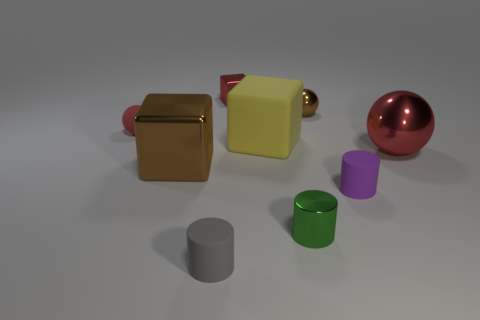What can you infer about the lighting condition in the scene? The shadows cast by the objects indicate that the lighting in the scene is coming from above, possibly slightly angled to one side. The soft-edged shadows suggest that the light source is not extremely close to the objects, and the diffusion of light indicates it might be an overcast or soft light condition, which gives the scene a calm and even lighting without harsh contrasts. 